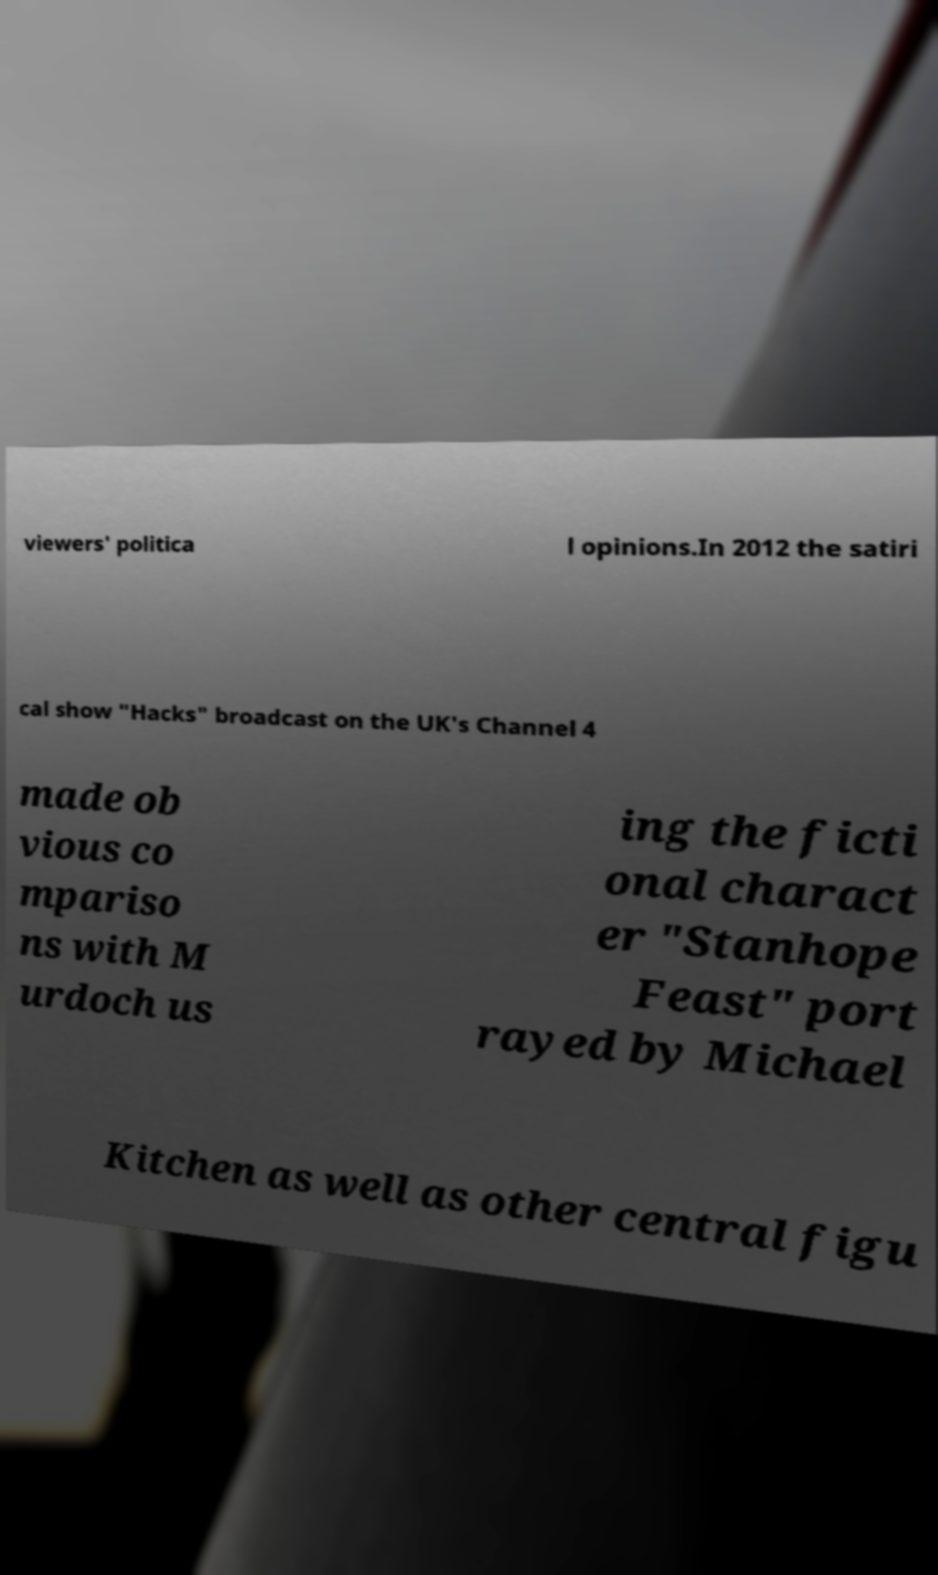Could you extract and type out the text from this image? viewers' politica l opinions.In 2012 the satiri cal show "Hacks" broadcast on the UK's Channel 4 made ob vious co mpariso ns with M urdoch us ing the ficti onal charact er "Stanhope Feast" port rayed by Michael Kitchen as well as other central figu 